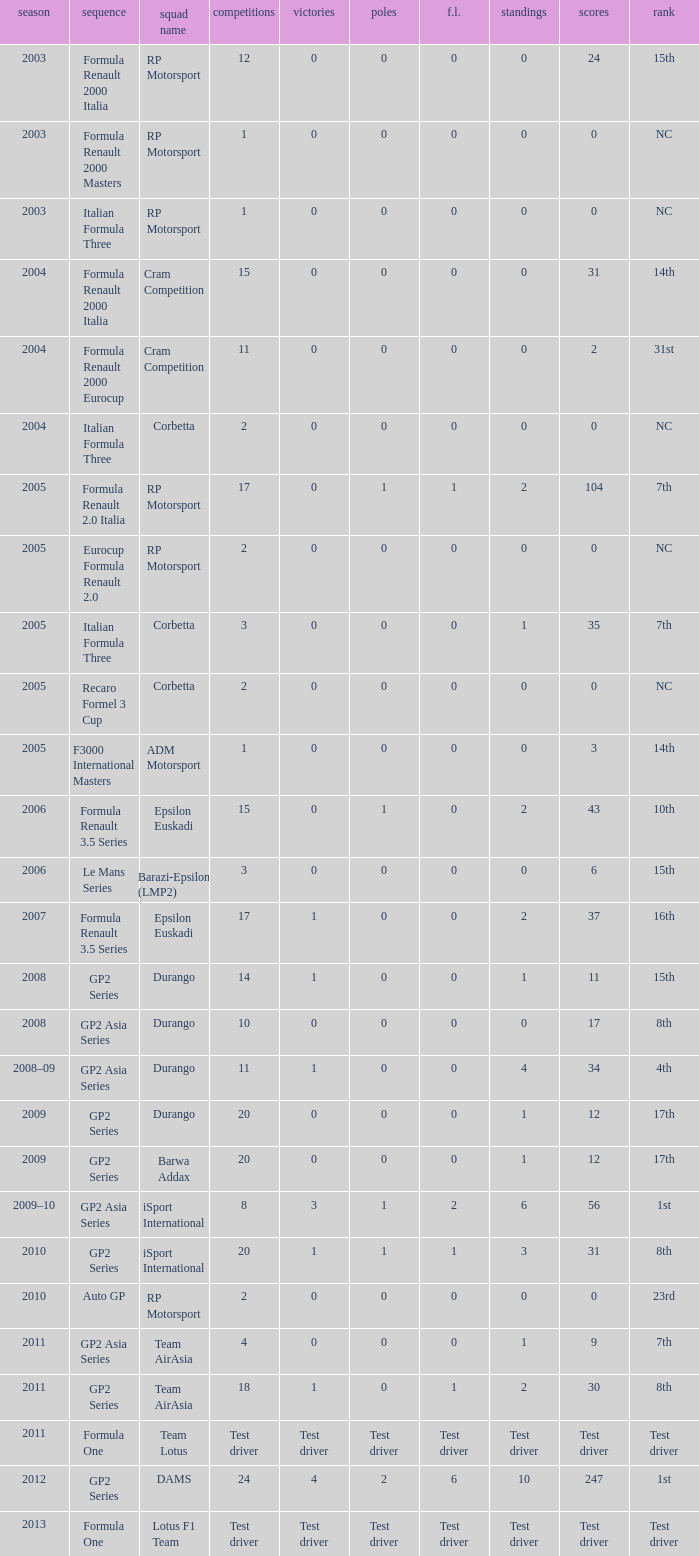What is the number of poles with 104 points? 1.0. 